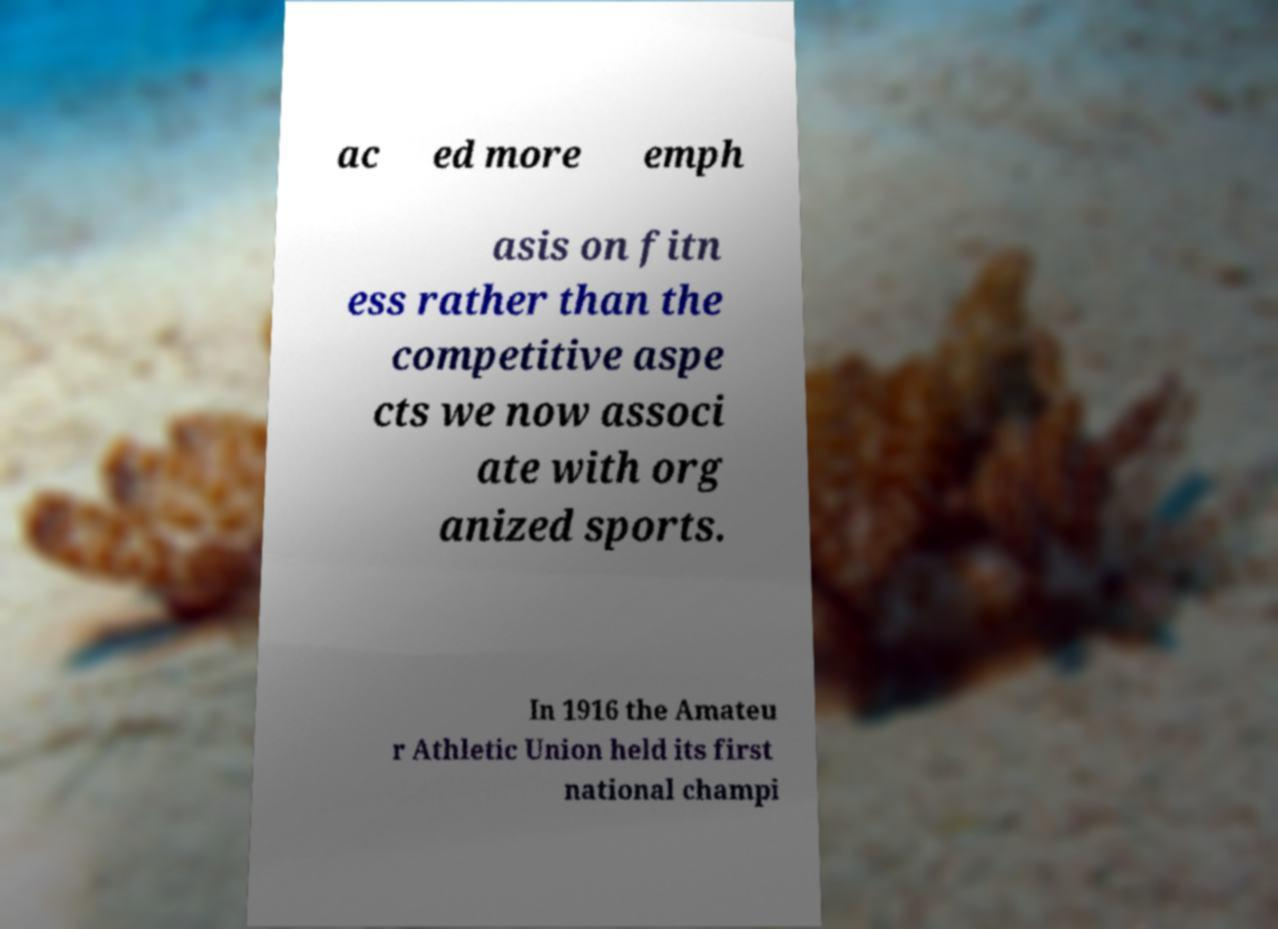What messages or text are displayed in this image? I need them in a readable, typed format. ac ed more emph asis on fitn ess rather than the competitive aspe cts we now associ ate with org anized sports. In 1916 the Amateu r Athletic Union held its first national champi 